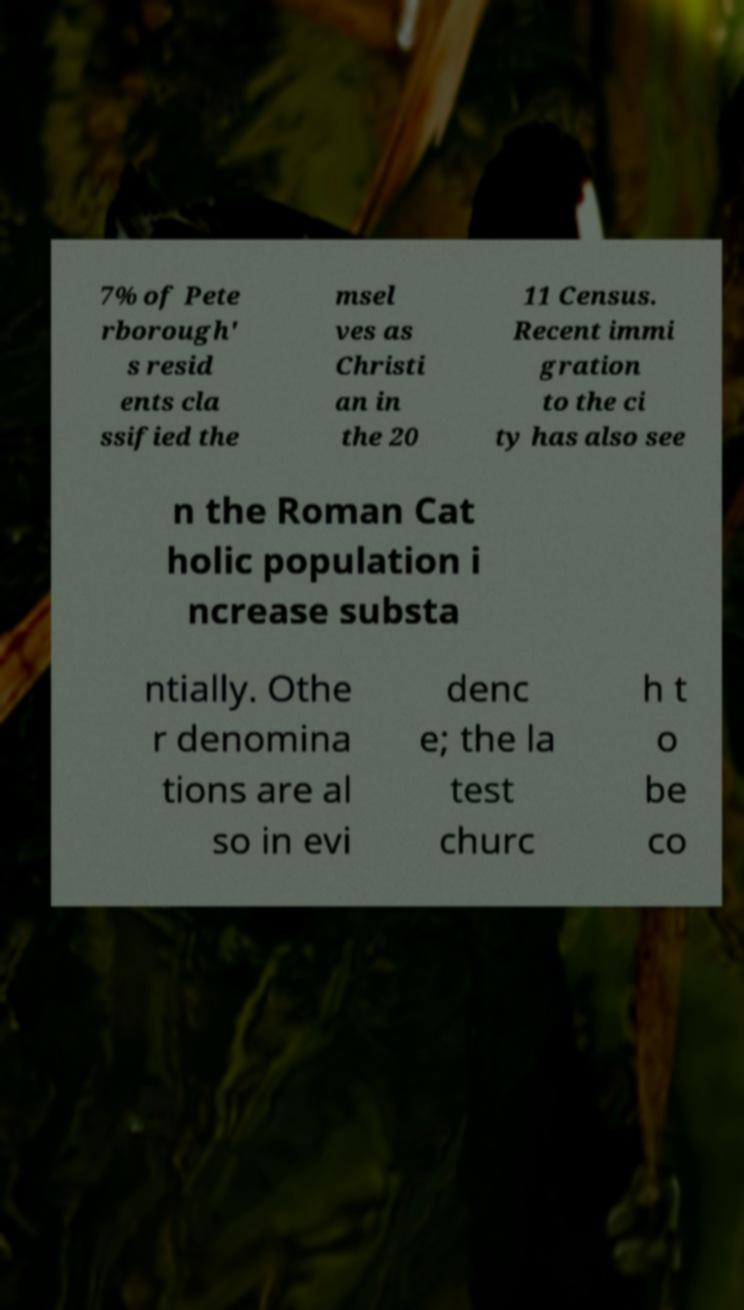Can you read and provide the text displayed in the image?This photo seems to have some interesting text. Can you extract and type it out for me? 7% of Pete rborough' s resid ents cla ssified the msel ves as Christi an in the 20 11 Census. Recent immi gration to the ci ty has also see n the Roman Cat holic population i ncrease substa ntially. Othe r denomina tions are al so in evi denc e; the la test churc h t o be co 